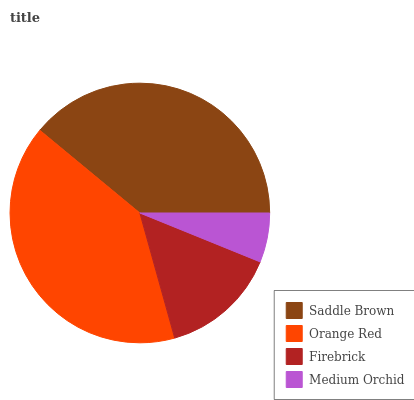Is Medium Orchid the minimum?
Answer yes or no. Yes. Is Orange Red the maximum?
Answer yes or no. Yes. Is Firebrick the minimum?
Answer yes or no. No. Is Firebrick the maximum?
Answer yes or no. No. Is Orange Red greater than Firebrick?
Answer yes or no. Yes. Is Firebrick less than Orange Red?
Answer yes or no. Yes. Is Firebrick greater than Orange Red?
Answer yes or no. No. Is Orange Red less than Firebrick?
Answer yes or no. No. Is Saddle Brown the high median?
Answer yes or no. Yes. Is Firebrick the low median?
Answer yes or no. Yes. Is Orange Red the high median?
Answer yes or no. No. Is Medium Orchid the low median?
Answer yes or no. No. 